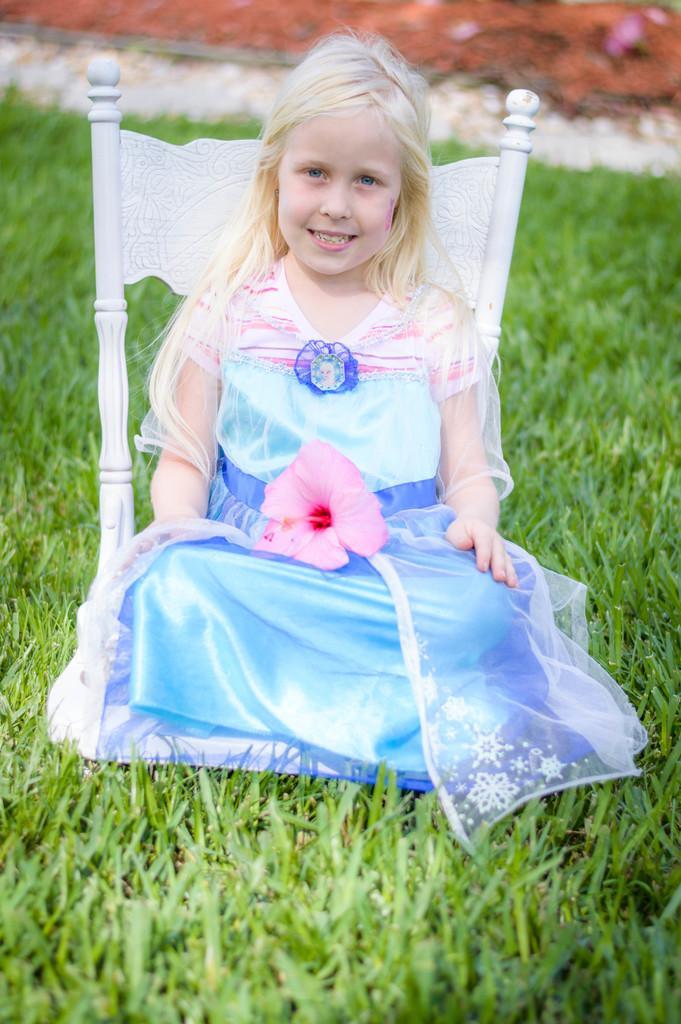How would you summarize this image in a sentence or two? In this image I see a girl who is smiling and she is wearing white, pink and blue color dress and there is a pink color flower on her and I see the white chair and I see the green grass. In the background I see the white and orange color thing and I see that it is blurred. 